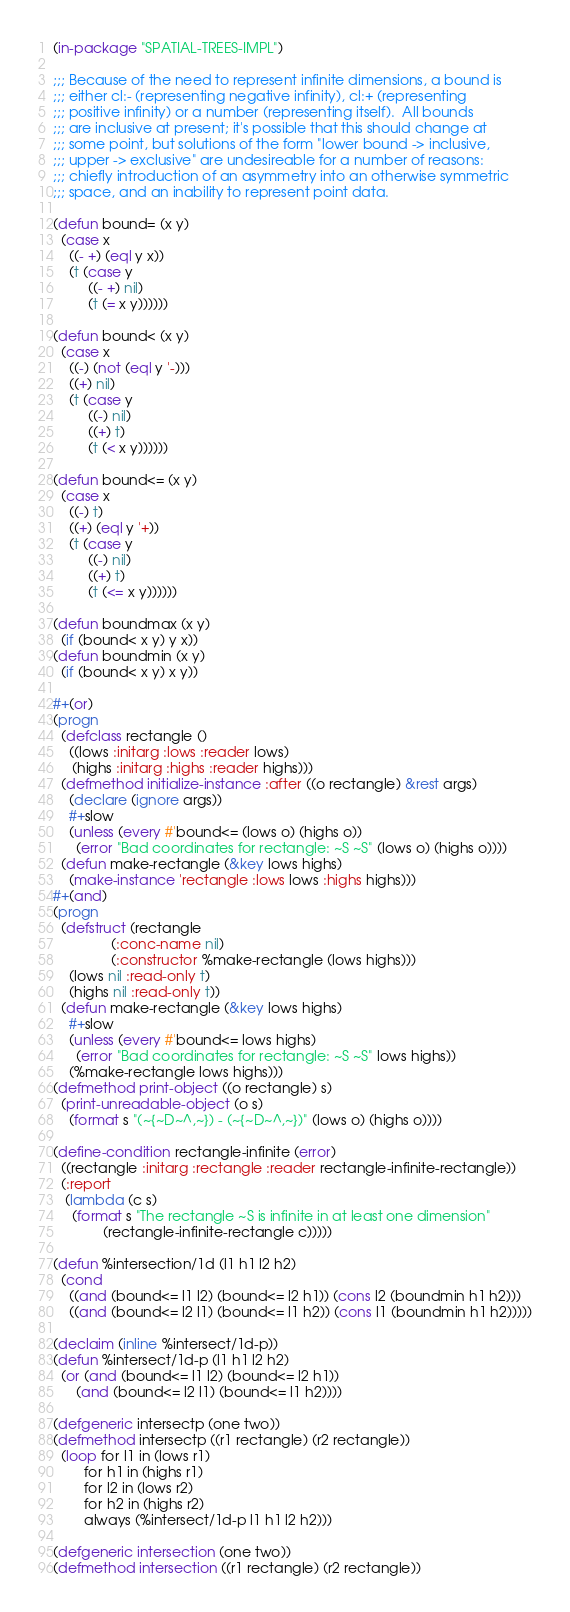<code> <loc_0><loc_0><loc_500><loc_500><_Lisp_>(in-package "SPATIAL-TREES-IMPL")

;;; Because of the need to represent infinite dimensions, a bound is
;;; either cl:- (representing negative infinity), cl:+ (representing
;;; positive infinity) or a number (representing itself).  All bounds
;;; are inclusive at present; it's possible that this should change at
;;; some point, but solutions of the form "lower bound -> inclusive,
;;; upper -> exclusive" are undesireable for a number of reasons:
;;; chiefly introduction of an asymmetry into an otherwise symmetric
;;; space, and an inability to represent point data.

(defun bound= (x y)
  (case x
    ((- +) (eql y x))
    (t (case y
         ((- +) nil)
         (t (= x y))))))

(defun bound< (x y)
  (case x
    ((-) (not (eql y '-)))
    ((+) nil)
    (t (case y
         ((-) nil)
         ((+) t)
         (t (< x y))))))

(defun bound<= (x y)
  (case x
    ((-) t)
    ((+) (eql y '+))
    (t (case y
         ((-) nil)
         ((+) t)
         (t (<= x y))))))

(defun boundmax (x y)
  (if (bound< x y) y x))
(defun boundmin (x y)
  (if (bound< x y) x y))

#+(or)
(progn
  (defclass rectangle ()
    ((lows :initarg :lows :reader lows)
     (highs :initarg :highs :reader highs)))
  (defmethod initialize-instance :after ((o rectangle) &rest args)
    (declare (ignore args))
    #+slow
    (unless (every #'bound<= (lows o) (highs o))
      (error "Bad coordinates for rectangle: ~S ~S" (lows o) (highs o))))
  (defun make-rectangle (&key lows highs)
    (make-instance 'rectangle :lows lows :highs highs)))
#+(and)
(progn
  (defstruct (rectangle
               (:conc-name nil)
               (:constructor %make-rectangle (lows highs)))
    (lows nil :read-only t)
    (highs nil :read-only t))
  (defun make-rectangle (&key lows highs)
    #+slow
    (unless (every #'bound<= lows highs)
      (error "Bad coordinates for rectangle: ~S ~S" lows highs))
    (%make-rectangle lows highs)))
(defmethod print-object ((o rectangle) s)
  (print-unreadable-object (o s)
    (format s "(~{~D~^,~}) - (~{~D~^,~})" (lows o) (highs o))))

(define-condition rectangle-infinite (error)
  ((rectangle :initarg :rectangle :reader rectangle-infinite-rectangle))
  (:report
   (lambda (c s)
     (format s "The rectangle ~S is infinite in at least one dimension"
             (rectangle-infinite-rectangle c)))))

(defun %intersection/1d (l1 h1 l2 h2)
  (cond
    ((and (bound<= l1 l2) (bound<= l2 h1)) (cons l2 (boundmin h1 h2)))
    ((and (bound<= l2 l1) (bound<= l1 h2)) (cons l1 (boundmin h1 h2)))))

(declaim (inline %intersect/1d-p))
(defun %intersect/1d-p (l1 h1 l2 h2)
  (or (and (bound<= l1 l2) (bound<= l2 h1))
      (and (bound<= l2 l1) (bound<= l1 h2))))

(defgeneric intersectp (one two))
(defmethod intersectp ((r1 rectangle) (r2 rectangle))
  (loop for l1 in (lows r1)
        for h1 in (highs r1)
        for l2 in (lows r2)
        for h2 in (highs r2)
        always (%intersect/1d-p l1 h1 l2 h2)))

(defgeneric intersection (one two))
(defmethod intersection ((r1 rectangle) (r2 rectangle))</code> 